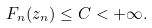<formula> <loc_0><loc_0><loc_500><loc_500>F _ { n } ( z _ { n } ) \leq C < + \infty .</formula> 